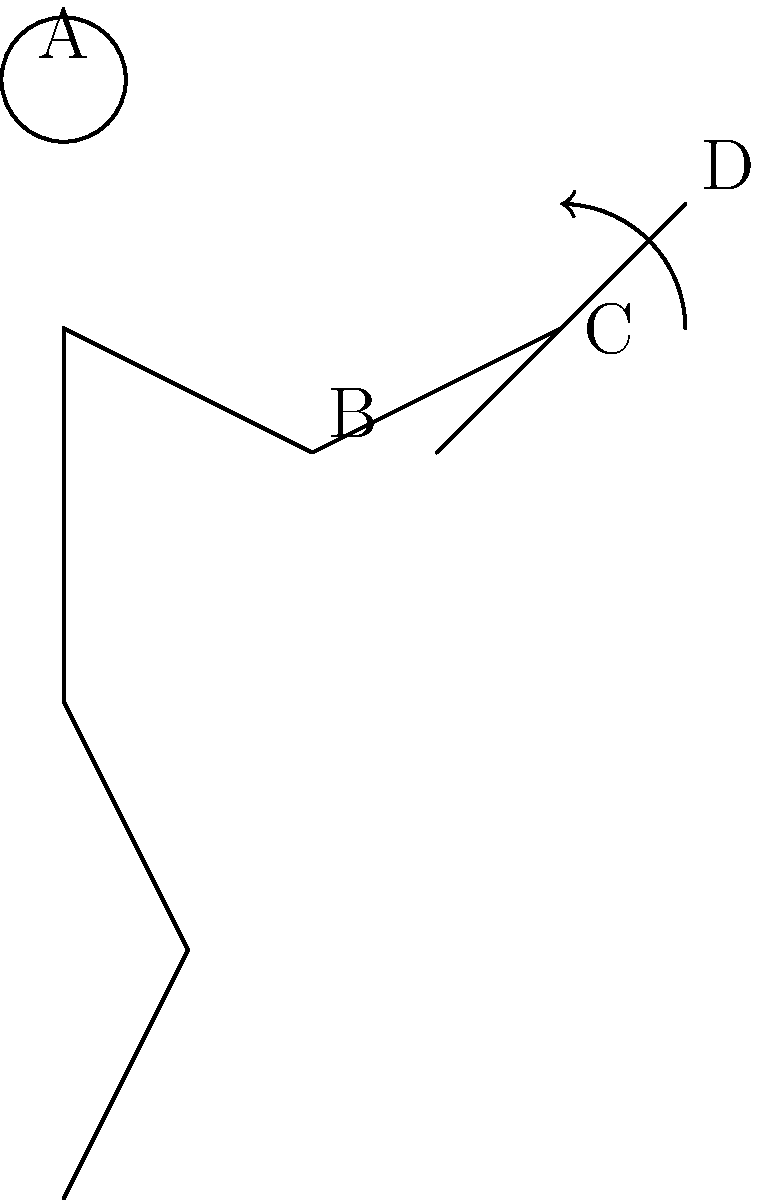In the stick figure representation of a cricket batting technique, which part of the body is most crucial for generating power in the shot shown, and why is it important for South African batsmen to master this technique? To answer this question, let's analyze the stick figure representation step-by-step:

1. The figure shows a batsman in a typical batting stance, with the bat raised and ready to play a shot.

2. The key points to observe are:
   A: Head (stable position)
   B: Elbow (bent at an angle)
   C: Wrist (flexed position)
   D: Top of the bat

3. The arrow near point C (wrist) indicates a rotational movement, which is crucial for shot execution.

4. In cricket batting, the wrist plays a vital role in generating power and controlling the direction of the shot. The rotation of the wrist allows for:
   a) Quick bat speed
   b) Late adjustment to the ball's line and length
   c) Increased power transfer from the body to the bat

5. For South African batsmen, mastering this wrist technique is particularly important because:
   a) Many South African pitches offer bounce and movement, requiring quick adjustments.
   b) It allows for effective playing of both pace and spin bowling, which is crucial in international cricket.
   c) It helps in adapting to different conditions when playing away from home, especially in the subcontinent where wrist play is crucial against spin.

6. Historically, many great South African batsmen like Jacques Kallis and AB de Villiers have excelled in using their wrists effectively, setting a benchmark for aspiring cricketers in the country.

Therefore, while all body parts contribute to shot-making, the wrist (point C) is most crucial for generating power and control in this particular technique.
Answer: Wrist (C), for power generation and adaptability to various pitch conditions. 